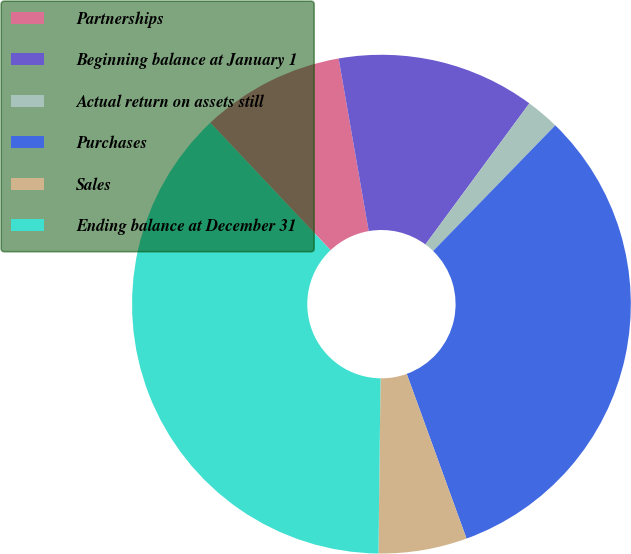<chart> <loc_0><loc_0><loc_500><loc_500><pie_chart><fcel>Partnerships<fcel>Beginning balance at January 1<fcel>Actual return on assets still<fcel>Purchases<fcel>Sales<fcel>Ending balance at December 31<nl><fcel>9.29%<fcel>12.85%<fcel>2.17%<fcel>32.18%<fcel>5.73%<fcel>37.77%<nl></chart> 